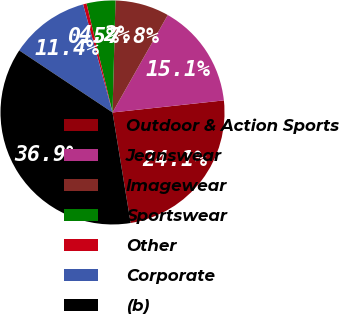Convert chart. <chart><loc_0><loc_0><loc_500><loc_500><pie_chart><fcel>Outdoor & Action Sports<fcel>Jeanswear<fcel>Imagewear<fcel>Sportswear<fcel>Other<fcel>Corporate<fcel>(b)<nl><fcel>24.13%<fcel>15.07%<fcel>7.79%<fcel>4.15%<fcel>0.5%<fcel>11.43%<fcel>36.93%<nl></chart> 